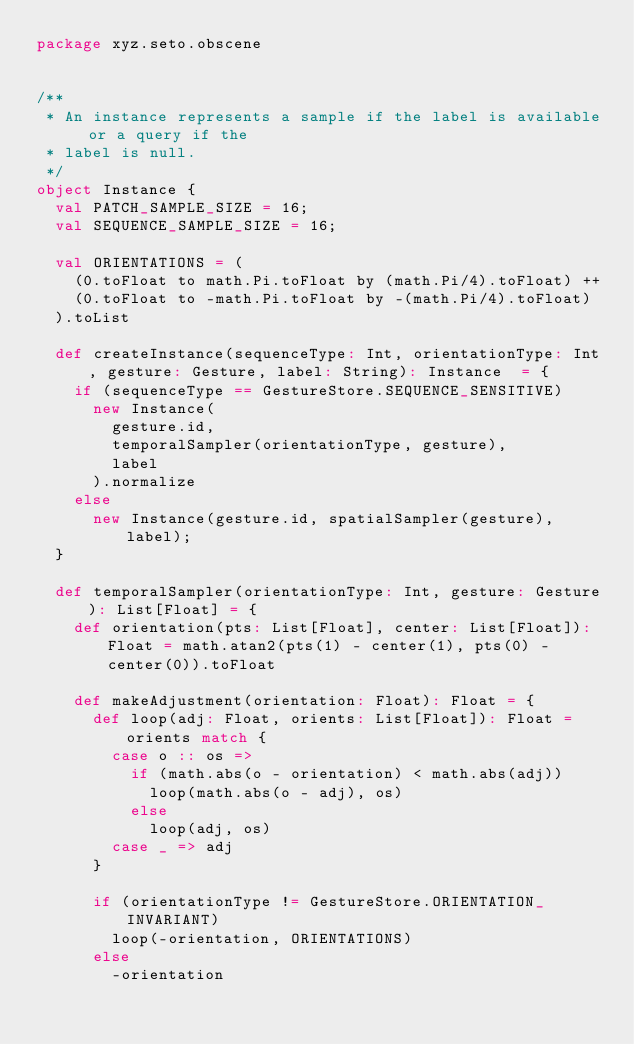Convert code to text. <code><loc_0><loc_0><loc_500><loc_500><_Scala_>package xyz.seto.obscene


/**
 * An instance represents a sample if the label is available or a query if the
 * label is null.
 */
object Instance {
  val PATCH_SAMPLE_SIZE = 16;
  val SEQUENCE_SAMPLE_SIZE = 16;

  val ORIENTATIONS = (
    (0.toFloat to math.Pi.toFloat by (math.Pi/4).toFloat) ++
    (0.toFloat to -math.Pi.toFloat by -(math.Pi/4).toFloat)
  ).toList

  def createInstance(sequenceType: Int, orientationType: Int, gesture: Gesture, label: String): Instance  = {
    if (sequenceType == GestureStore.SEQUENCE_SENSITIVE)
      new Instance(
        gesture.id,
        temporalSampler(orientationType, gesture),
        label
      ).normalize
    else
      new Instance(gesture.id, spatialSampler(gesture), label);
  }

  def temporalSampler(orientationType: Int, gesture: Gesture): List[Float] = {
    def orientation(pts: List[Float], center: List[Float]): Float = math.atan2(pts(1) - center(1), pts(0) - center(0)).toFloat

    def makeAdjustment(orientation: Float): Float = {
      def loop(adj: Float, orients: List[Float]): Float = orients match {
        case o :: os =>
          if (math.abs(o - orientation) < math.abs(adj))
            loop(math.abs(o - adj), os)
          else
            loop(adj, os)
        case _ => adj
      }

      if (orientationType != GestureStore.ORIENTATION_INVARIANT)
        loop(-orientation, ORIENTATIONS)
      else
        -orientation</code> 